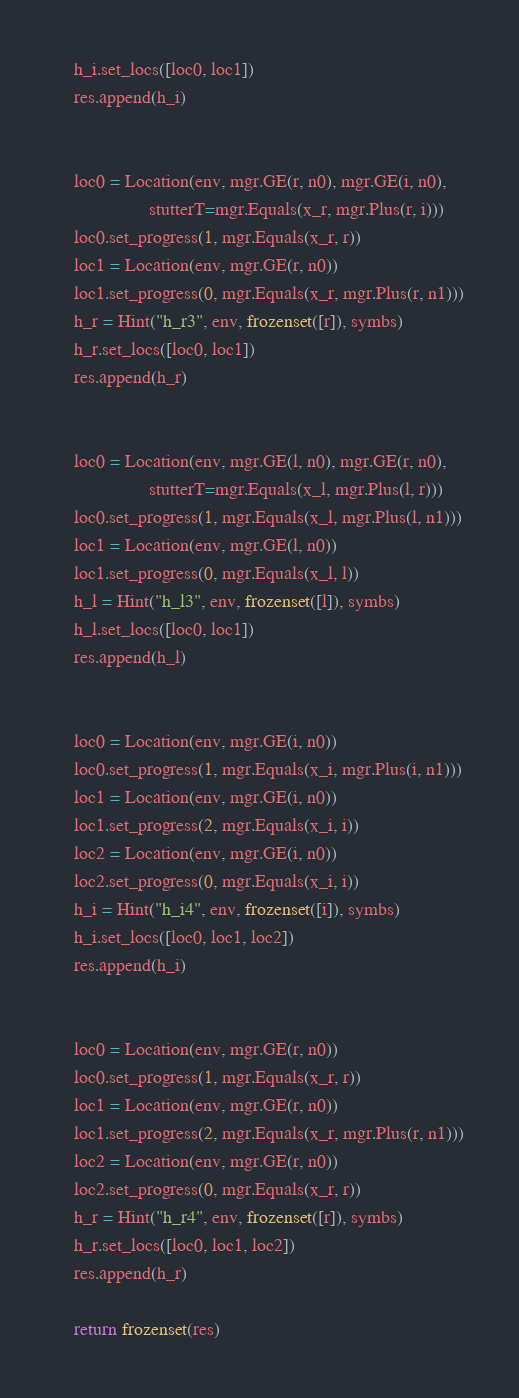Convert code to text. <code><loc_0><loc_0><loc_500><loc_500><_Python_>    h_i.set_locs([loc0, loc1])
    res.append(h_i)


    loc0 = Location(env, mgr.GE(r, n0), mgr.GE(i, n0),
                    stutterT=mgr.Equals(x_r, mgr.Plus(r, i)))
    loc0.set_progress(1, mgr.Equals(x_r, r))
    loc1 = Location(env, mgr.GE(r, n0))
    loc1.set_progress(0, mgr.Equals(x_r, mgr.Plus(r, n1)))
    h_r = Hint("h_r3", env, frozenset([r]), symbs)
    h_r.set_locs([loc0, loc1])
    res.append(h_r)


    loc0 = Location(env, mgr.GE(l, n0), mgr.GE(r, n0),
                    stutterT=mgr.Equals(x_l, mgr.Plus(l, r)))
    loc0.set_progress(1, mgr.Equals(x_l, mgr.Plus(l, n1)))
    loc1 = Location(env, mgr.GE(l, n0))
    loc1.set_progress(0, mgr.Equals(x_l, l))
    h_l = Hint("h_l3", env, frozenset([l]), symbs)
    h_l.set_locs([loc0, loc1])
    res.append(h_l)


    loc0 = Location(env, mgr.GE(i, n0))
    loc0.set_progress(1, mgr.Equals(x_i, mgr.Plus(i, n1)))
    loc1 = Location(env, mgr.GE(i, n0))
    loc1.set_progress(2, mgr.Equals(x_i, i))
    loc2 = Location(env, mgr.GE(i, n0))
    loc2.set_progress(0, mgr.Equals(x_i, i))
    h_i = Hint("h_i4", env, frozenset([i]), symbs)
    h_i.set_locs([loc0, loc1, loc2])
    res.append(h_i)


    loc0 = Location(env, mgr.GE(r, n0))
    loc0.set_progress(1, mgr.Equals(x_r, r))
    loc1 = Location(env, mgr.GE(r, n0))
    loc1.set_progress(2, mgr.Equals(x_r, mgr.Plus(r, n1)))
    loc2 = Location(env, mgr.GE(r, n0))
    loc2.set_progress(0, mgr.Equals(x_r, r))
    h_r = Hint("h_r4", env, frozenset([r]), symbs)
    h_r.set_locs([loc0, loc1, loc2])
    res.append(h_r)

    return frozenset(res)
</code> 